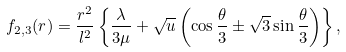<formula> <loc_0><loc_0><loc_500><loc_500>f _ { 2 , 3 } ( r ) = \frac { r ^ { 2 } } { l ^ { 2 } } \left \{ \frac { \lambda } { 3 \mu } + \sqrt { u } \left ( \cos \frac { \theta } { 3 } \pm \sqrt { 3 } \sin \frac { \theta } { 3 } \right ) \right \} ,</formula> 